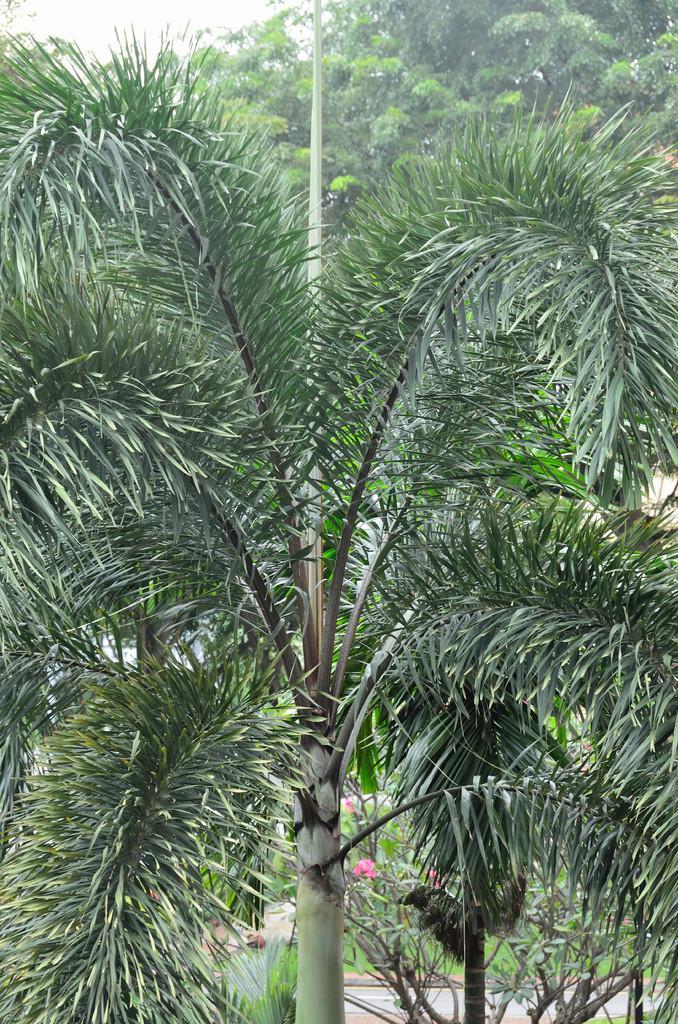Describe this image in one or two sentences. In this image I can see a tree which is green in color. I can see few plants and few flowers which are pink in color. I can see few trees and the sky in the background. 